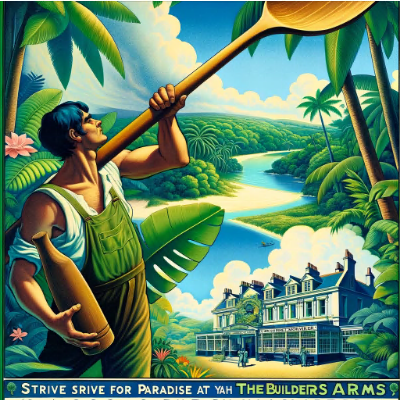Is it possible that this image is AI generated? The image you've provided appears to be a piece of artwork rather than a photograph. While it is theoretically possible for artwork to be generated by AI, the image here has a style that is more indicative of traditional hand-drawn or painted illustration, potentially inspired by vintage travel posters or similar aesthetics.

AI has become quite adept at creating images that mimic various artistic styles, but determining whether this specific image is AI-generated would require more context about its origin, the artist, or the method used to create it. Without that information, it's not possible to definitively state whether it is AI-generated or not. However, the crisp lines, vibrant colors, and stylized depiction are all within the capabilities of a human artist. 